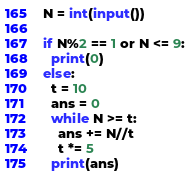<code> <loc_0><loc_0><loc_500><loc_500><_Python_>N = int(input())

if N%2 == 1 or N <= 9:
  print(0)
else:
  t = 10
  ans = 0
  while N >= t:
    ans += N//t
    t *= 5
  print(ans)</code> 